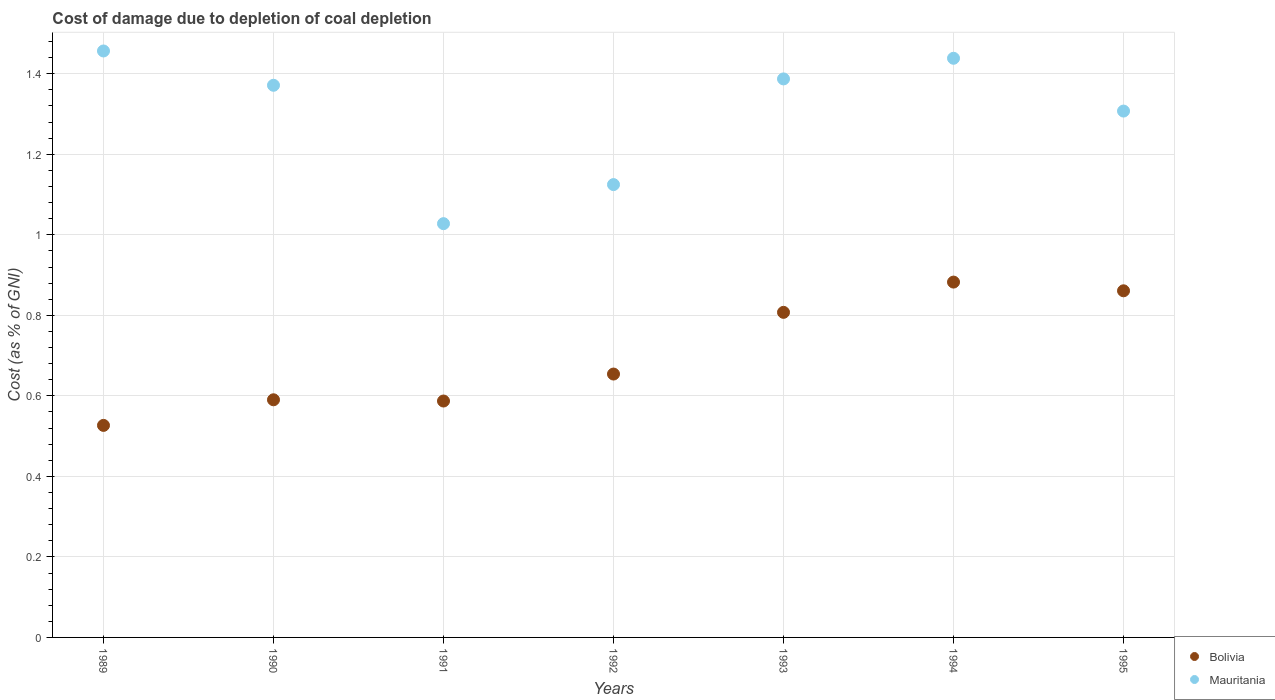How many different coloured dotlines are there?
Your response must be concise. 2. What is the cost of damage caused due to coal depletion in Bolivia in 1990?
Provide a succinct answer. 0.59. Across all years, what is the maximum cost of damage caused due to coal depletion in Bolivia?
Make the answer very short. 0.88. Across all years, what is the minimum cost of damage caused due to coal depletion in Mauritania?
Offer a very short reply. 1.03. What is the total cost of damage caused due to coal depletion in Bolivia in the graph?
Your response must be concise. 4.91. What is the difference between the cost of damage caused due to coal depletion in Bolivia in 1989 and that in 1990?
Your response must be concise. -0.06. What is the difference between the cost of damage caused due to coal depletion in Bolivia in 1991 and the cost of damage caused due to coal depletion in Mauritania in 1992?
Offer a very short reply. -0.54. What is the average cost of damage caused due to coal depletion in Mauritania per year?
Make the answer very short. 1.3. In the year 1992, what is the difference between the cost of damage caused due to coal depletion in Bolivia and cost of damage caused due to coal depletion in Mauritania?
Ensure brevity in your answer.  -0.47. What is the ratio of the cost of damage caused due to coal depletion in Bolivia in 1993 to that in 1995?
Offer a terse response. 0.94. Is the cost of damage caused due to coal depletion in Bolivia in 1989 less than that in 1995?
Offer a terse response. Yes. What is the difference between the highest and the second highest cost of damage caused due to coal depletion in Mauritania?
Your response must be concise. 0.02. What is the difference between the highest and the lowest cost of damage caused due to coal depletion in Mauritania?
Give a very brief answer. 0.43. Does the cost of damage caused due to coal depletion in Bolivia monotonically increase over the years?
Keep it short and to the point. No. Is the cost of damage caused due to coal depletion in Bolivia strictly greater than the cost of damage caused due to coal depletion in Mauritania over the years?
Ensure brevity in your answer.  No. Is the cost of damage caused due to coal depletion in Bolivia strictly less than the cost of damage caused due to coal depletion in Mauritania over the years?
Keep it short and to the point. Yes. How many dotlines are there?
Ensure brevity in your answer.  2. How many years are there in the graph?
Your response must be concise. 7. What is the difference between two consecutive major ticks on the Y-axis?
Your answer should be very brief. 0.2. Are the values on the major ticks of Y-axis written in scientific E-notation?
Give a very brief answer. No. Does the graph contain any zero values?
Your answer should be compact. No. How are the legend labels stacked?
Keep it short and to the point. Vertical. What is the title of the graph?
Keep it short and to the point. Cost of damage due to depletion of coal depletion. Does "High income: nonOECD" appear as one of the legend labels in the graph?
Your response must be concise. No. What is the label or title of the Y-axis?
Provide a succinct answer. Cost (as % of GNI). What is the Cost (as % of GNI) in Bolivia in 1989?
Your answer should be very brief. 0.53. What is the Cost (as % of GNI) in Mauritania in 1989?
Your response must be concise. 1.46. What is the Cost (as % of GNI) in Bolivia in 1990?
Your answer should be very brief. 0.59. What is the Cost (as % of GNI) in Mauritania in 1990?
Give a very brief answer. 1.37. What is the Cost (as % of GNI) in Bolivia in 1991?
Your answer should be very brief. 0.59. What is the Cost (as % of GNI) of Mauritania in 1991?
Offer a terse response. 1.03. What is the Cost (as % of GNI) in Bolivia in 1992?
Offer a very short reply. 0.65. What is the Cost (as % of GNI) in Mauritania in 1992?
Provide a succinct answer. 1.12. What is the Cost (as % of GNI) in Bolivia in 1993?
Ensure brevity in your answer.  0.81. What is the Cost (as % of GNI) of Mauritania in 1993?
Keep it short and to the point. 1.39. What is the Cost (as % of GNI) in Bolivia in 1994?
Keep it short and to the point. 0.88. What is the Cost (as % of GNI) of Mauritania in 1994?
Offer a terse response. 1.44. What is the Cost (as % of GNI) of Bolivia in 1995?
Your answer should be very brief. 0.86. What is the Cost (as % of GNI) of Mauritania in 1995?
Provide a succinct answer. 1.31. Across all years, what is the maximum Cost (as % of GNI) in Bolivia?
Your response must be concise. 0.88. Across all years, what is the maximum Cost (as % of GNI) of Mauritania?
Give a very brief answer. 1.46. Across all years, what is the minimum Cost (as % of GNI) of Bolivia?
Give a very brief answer. 0.53. Across all years, what is the minimum Cost (as % of GNI) of Mauritania?
Your answer should be compact. 1.03. What is the total Cost (as % of GNI) in Bolivia in the graph?
Provide a short and direct response. 4.91. What is the total Cost (as % of GNI) of Mauritania in the graph?
Your answer should be compact. 9.11. What is the difference between the Cost (as % of GNI) of Bolivia in 1989 and that in 1990?
Offer a very short reply. -0.06. What is the difference between the Cost (as % of GNI) in Mauritania in 1989 and that in 1990?
Keep it short and to the point. 0.09. What is the difference between the Cost (as % of GNI) in Bolivia in 1989 and that in 1991?
Give a very brief answer. -0.06. What is the difference between the Cost (as % of GNI) of Mauritania in 1989 and that in 1991?
Provide a succinct answer. 0.43. What is the difference between the Cost (as % of GNI) of Bolivia in 1989 and that in 1992?
Provide a succinct answer. -0.13. What is the difference between the Cost (as % of GNI) in Mauritania in 1989 and that in 1992?
Keep it short and to the point. 0.33. What is the difference between the Cost (as % of GNI) in Bolivia in 1989 and that in 1993?
Provide a succinct answer. -0.28. What is the difference between the Cost (as % of GNI) of Mauritania in 1989 and that in 1993?
Provide a short and direct response. 0.07. What is the difference between the Cost (as % of GNI) in Bolivia in 1989 and that in 1994?
Ensure brevity in your answer.  -0.36. What is the difference between the Cost (as % of GNI) in Mauritania in 1989 and that in 1994?
Ensure brevity in your answer.  0.02. What is the difference between the Cost (as % of GNI) in Bolivia in 1989 and that in 1995?
Give a very brief answer. -0.33. What is the difference between the Cost (as % of GNI) in Mauritania in 1989 and that in 1995?
Your answer should be compact. 0.15. What is the difference between the Cost (as % of GNI) of Bolivia in 1990 and that in 1991?
Your response must be concise. 0. What is the difference between the Cost (as % of GNI) of Mauritania in 1990 and that in 1991?
Offer a very short reply. 0.34. What is the difference between the Cost (as % of GNI) of Bolivia in 1990 and that in 1992?
Offer a very short reply. -0.06. What is the difference between the Cost (as % of GNI) of Mauritania in 1990 and that in 1992?
Your answer should be compact. 0.25. What is the difference between the Cost (as % of GNI) of Bolivia in 1990 and that in 1993?
Keep it short and to the point. -0.22. What is the difference between the Cost (as % of GNI) in Mauritania in 1990 and that in 1993?
Keep it short and to the point. -0.02. What is the difference between the Cost (as % of GNI) in Bolivia in 1990 and that in 1994?
Provide a short and direct response. -0.29. What is the difference between the Cost (as % of GNI) in Mauritania in 1990 and that in 1994?
Keep it short and to the point. -0.07. What is the difference between the Cost (as % of GNI) of Bolivia in 1990 and that in 1995?
Your answer should be compact. -0.27. What is the difference between the Cost (as % of GNI) of Mauritania in 1990 and that in 1995?
Make the answer very short. 0.06. What is the difference between the Cost (as % of GNI) in Bolivia in 1991 and that in 1992?
Your answer should be compact. -0.07. What is the difference between the Cost (as % of GNI) of Mauritania in 1991 and that in 1992?
Give a very brief answer. -0.1. What is the difference between the Cost (as % of GNI) in Bolivia in 1991 and that in 1993?
Offer a terse response. -0.22. What is the difference between the Cost (as % of GNI) of Mauritania in 1991 and that in 1993?
Ensure brevity in your answer.  -0.36. What is the difference between the Cost (as % of GNI) in Bolivia in 1991 and that in 1994?
Your answer should be very brief. -0.3. What is the difference between the Cost (as % of GNI) in Mauritania in 1991 and that in 1994?
Offer a terse response. -0.41. What is the difference between the Cost (as % of GNI) in Bolivia in 1991 and that in 1995?
Ensure brevity in your answer.  -0.27. What is the difference between the Cost (as % of GNI) in Mauritania in 1991 and that in 1995?
Provide a succinct answer. -0.28. What is the difference between the Cost (as % of GNI) of Bolivia in 1992 and that in 1993?
Your answer should be compact. -0.15. What is the difference between the Cost (as % of GNI) in Mauritania in 1992 and that in 1993?
Provide a succinct answer. -0.26. What is the difference between the Cost (as % of GNI) in Bolivia in 1992 and that in 1994?
Offer a terse response. -0.23. What is the difference between the Cost (as % of GNI) of Mauritania in 1992 and that in 1994?
Ensure brevity in your answer.  -0.31. What is the difference between the Cost (as % of GNI) of Bolivia in 1992 and that in 1995?
Ensure brevity in your answer.  -0.21. What is the difference between the Cost (as % of GNI) of Mauritania in 1992 and that in 1995?
Your answer should be compact. -0.18. What is the difference between the Cost (as % of GNI) in Bolivia in 1993 and that in 1994?
Your answer should be compact. -0.08. What is the difference between the Cost (as % of GNI) in Mauritania in 1993 and that in 1994?
Ensure brevity in your answer.  -0.05. What is the difference between the Cost (as % of GNI) in Bolivia in 1993 and that in 1995?
Keep it short and to the point. -0.05. What is the difference between the Cost (as % of GNI) of Mauritania in 1993 and that in 1995?
Make the answer very short. 0.08. What is the difference between the Cost (as % of GNI) in Bolivia in 1994 and that in 1995?
Provide a succinct answer. 0.02. What is the difference between the Cost (as % of GNI) of Mauritania in 1994 and that in 1995?
Provide a short and direct response. 0.13. What is the difference between the Cost (as % of GNI) of Bolivia in 1989 and the Cost (as % of GNI) of Mauritania in 1990?
Your response must be concise. -0.84. What is the difference between the Cost (as % of GNI) of Bolivia in 1989 and the Cost (as % of GNI) of Mauritania in 1991?
Make the answer very short. -0.5. What is the difference between the Cost (as % of GNI) of Bolivia in 1989 and the Cost (as % of GNI) of Mauritania in 1992?
Your answer should be very brief. -0.6. What is the difference between the Cost (as % of GNI) of Bolivia in 1989 and the Cost (as % of GNI) of Mauritania in 1993?
Your answer should be compact. -0.86. What is the difference between the Cost (as % of GNI) in Bolivia in 1989 and the Cost (as % of GNI) in Mauritania in 1994?
Your response must be concise. -0.91. What is the difference between the Cost (as % of GNI) of Bolivia in 1989 and the Cost (as % of GNI) of Mauritania in 1995?
Keep it short and to the point. -0.78. What is the difference between the Cost (as % of GNI) of Bolivia in 1990 and the Cost (as % of GNI) of Mauritania in 1991?
Give a very brief answer. -0.44. What is the difference between the Cost (as % of GNI) of Bolivia in 1990 and the Cost (as % of GNI) of Mauritania in 1992?
Provide a succinct answer. -0.53. What is the difference between the Cost (as % of GNI) of Bolivia in 1990 and the Cost (as % of GNI) of Mauritania in 1993?
Provide a succinct answer. -0.8. What is the difference between the Cost (as % of GNI) of Bolivia in 1990 and the Cost (as % of GNI) of Mauritania in 1994?
Provide a short and direct response. -0.85. What is the difference between the Cost (as % of GNI) in Bolivia in 1990 and the Cost (as % of GNI) in Mauritania in 1995?
Provide a succinct answer. -0.72. What is the difference between the Cost (as % of GNI) of Bolivia in 1991 and the Cost (as % of GNI) of Mauritania in 1992?
Offer a terse response. -0.54. What is the difference between the Cost (as % of GNI) of Bolivia in 1991 and the Cost (as % of GNI) of Mauritania in 1993?
Offer a very short reply. -0.8. What is the difference between the Cost (as % of GNI) of Bolivia in 1991 and the Cost (as % of GNI) of Mauritania in 1994?
Ensure brevity in your answer.  -0.85. What is the difference between the Cost (as % of GNI) in Bolivia in 1991 and the Cost (as % of GNI) in Mauritania in 1995?
Make the answer very short. -0.72. What is the difference between the Cost (as % of GNI) of Bolivia in 1992 and the Cost (as % of GNI) of Mauritania in 1993?
Provide a succinct answer. -0.73. What is the difference between the Cost (as % of GNI) in Bolivia in 1992 and the Cost (as % of GNI) in Mauritania in 1994?
Your response must be concise. -0.78. What is the difference between the Cost (as % of GNI) in Bolivia in 1992 and the Cost (as % of GNI) in Mauritania in 1995?
Your response must be concise. -0.65. What is the difference between the Cost (as % of GNI) in Bolivia in 1993 and the Cost (as % of GNI) in Mauritania in 1994?
Keep it short and to the point. -0.63. What is the difference between the Cost (as % of GNI) in Bolivia in 1993 and the Cost (as % of GNI) in Mauritania in 1995?
Ensure brevity in your answer.  -0.5. What is the difference between the Cost (as % of GNI) of Bolivia in 1994 and the Cost (as % of GNI) of Mauritania in 1995?
Offer a very short reply. -0.42. What is the average Cost (as % of GNI) in Bolivia per year?
Keep it short and to the point. 0.7. What is the average Cost (as % of GNI) of Mauritania per year?
Give a very brief answer. 1.3. In the year 1989, what is the difference between the Cost (as % of GNI) in Bolivia and Cost (as % of GNI) in Mauritania?
Give a very brief answer. -0.93. In the year 1990, what is the difference between the Cost (as % of GNI) of Bolivia and Cost (as % of GNI) of Mauritania?
Make the answer very short. -0.78. In the year 1991, what is the difference between the Cost (as % of GNI) of Bolivia and Cost (as % of GNI) of Mauritania?
Keep it short and to the point. -0.44. In the year 1992, what is the difference between the Cost (as % of GNI) of Bolivia and Cost (as % of GNI) of Mauritania?
Provide a short and direct response. -0.47. In the year 1993, what is the difference between the Cost (as % of GNI) in Bolivia and Cost (as % of GNI) in Mauritania?
Make the answer very short. -0.58. In the year 1994, what is the difference between the Cost (as % of GNI) of Bolivia and Cost (as % of GNI) of Mauritania?
Give a very brief answer. -0.56. In the year 1995, what is the difference between the Cost (as % of GNI) in Bolivia and Cost (as % of GNI) in Mauritania?
Offer a very short reply. -0.45. What is the ratio of the Cost (as % of GNI) of Bolivia in 1989 to that in 1990?
Provide a short and direct response. 0.89. What is the ratio of the Cost (as % of GNI) of Mauritania in 1989 to that in 1990?
Offer a very short reply. 1.06. What is the ratio of the Cost (as % of GNI) of Bolivia in 1989 to that in 1991?
Make the answer very short. 0.9. What is the ratio of the Cost (as % of GNI) of Mauritania in 1989 to that in 1991?
Make the answer very short. 1.42. What is the ratio of the Cost (as % of GNI) of Bolivia in 1989 to that in 1992?
Give a very brief answer. 0.81. What is the ratio of the Cost (as % of GNI) in Mauritania in 1989 to that in 1992?
Your answer should be very brief. 1.3. What is the ratio of the Cost (as % of GNI) of Bolivia in 1989 to that in 1993?
Keep it short and to the point. 0.65. What is the ratio of the Cost (as % of GNI) of Bolivia in 1989 to that in 1994?
Your answer should be compact. 0.6. What is the ratio of the Cost (as % of GNI) of Mauritania in 1989 to that in 1994?
Offer a very short reply. 1.01. What is the ratio of the Cost (as % of GNI) in Bolivia in 1989 to that in 1995?
Give a very brief answer. 0.61. What is the ratio of the Cost (as % of GNI) of Mauritania in 1989 to that in 1995?
Ensure brevity in your answer.  1.11. What is the ratio of the Cost (as % of GNI) of Bolivia in 1990 to that in 1991?
Your answer should be compact. 1.01. What is the ratio of the Cost (as % of GNI) in Mauritania in 1990 to that in 1991?
Your answer should be very brief. 1.33. What is the ratio of the Cost (as % of GNI) of Bolivia in 1990 to that in 1992?
Make the answer very short. 0.9. What is the ratio of the Cost (as % of GNI) of Mauritania in 1990 to that in 1992?
Your answer should be compact. 1.22. What is the ratio of the Cost (as % of GNI) of Bolivia in 1990 to that in 1993?
Your answer should be very brief. 0.73. What is the ratio of the Cost (as % of GNI) of Bolivia in 1990 to that in 1994?
Make the answer very short. 0.67. What is the ratio of the Cost (as % of GNI) in Mauritania in 1990 to that in 1994?
Your answer should be compact. 0.95. What is the ratio of the Cost (as % of GNI) of Bolivia in 1990 to that in 1995?
Ensure brevity in your answer.  0.69. What is the ratio of the Cost (as % of GNI) of Mauritania in 1990 to that in 1995?
Keep it short and to the point. 1.05. What is the ratio of the Cost (as % of GNI) of Bolivia in 1991 to that in 1992?
Provide a short and direct response. 0.9. What is the ratio of the Cost (as % of GNI) of Mauritania in 1991 to that in 1992?
Make the answer very short. 0.91. What is the ratio of the Cost (as % of GNI) of Bolivia in 1991 to that in 1993?
Give a very brief answer. 0.73. What is the ratio of the Cost (as % of GNI) in Mauritania in 1991 to that in 1993?
Ensure brevity in your answer.  0.74. What is the ratio of the Cost (as % of GNI) in Bolivia in 1991 to that in 1994?
Provide a succinct answer. 0.67. What is the ratio of the Cost (as % of GNI) in Mauritania in 1991 to that in 1994?
Offer a very short reply. 0.71. What is the ratio of the Cost (as % of GNI) in Bolivia in 1991 to that in 1995?
Give a very brief answer. 0.68. What is the ratio of the Cost (as % of GNI) in Mauritania in 1991 to that in 1995?
Keep it short and to the point. 0.79. What is the ratio of the Cost (as % of GNI) in Bolivia in 1992 to that in 1993?
Ensure brevity in your answer.  0.81. What is the ratio of the Cost (as % of GNI) in Mauritania in 1992 to that in 1993?
Provide a succinct answer. 0.81. What is the ratio of the Cost (as % of GNI) in Bolivia in 1992 to that in 1994?
Make the answer very short. 0.74. What is the ratio of the Cost (as % of GNI) in Mauritania in 1992 to that in 1994?
Your answer should be compact. 0.78. What is the ratio of the Cost (as % of GNI) of Bolivia in 1992 to that in 1995?
Offer a very short reply. 0.76. What is the ratio of the Cost (as % of GNI) in Mauritania in 1992 to that in 1995?
Make the answer very short. 0.86. What is the ratio of the Cost (as % of GNI) in Bolivia in 1993 to that in 1994?
Your answer should be compact. 0.91. What is the ratio of the Cost (as % of GNI) in Mauritania in 1993 to that in 1994?
Offer a terse response. 0.96. What is the ratio of the Cost (as % of GNI) of Bolivia in 1993 to that in 1995?
Your answer should be compact. 0.94. What is the ratio of the Cost (as % of GNI) in Mauritania in 1993 to that in 1995?
Provide a short and direct response. 1.06. What is the ratio of the Cost (as % of GNI) in Bolivia in 1994 to that in 1995?
Provide a short and direct response. 1.03. What is the ratio of the Cost (as % of GNI) of Mauritania in 1994 to that in 1995?
Ensure brevity in your answer.  1.1. What is the difference between the highest and the second highest Cost (as % of GNI) in Bolivia?
Offer a terse response. 0.02. What is the difference between the highest and the second highest Cost (as % of GNI) in Mauritania?
Provide a short and direct response. 0.02. What is the difference between the highest and the lowest Cost (as % of GNI) in Bolivia?
Your answer should be compact. 0.36. What is the difference between the highest and the lowest Cost (as % of GNI) in Mauritania?
Keep it short and to the point. 0.43. 